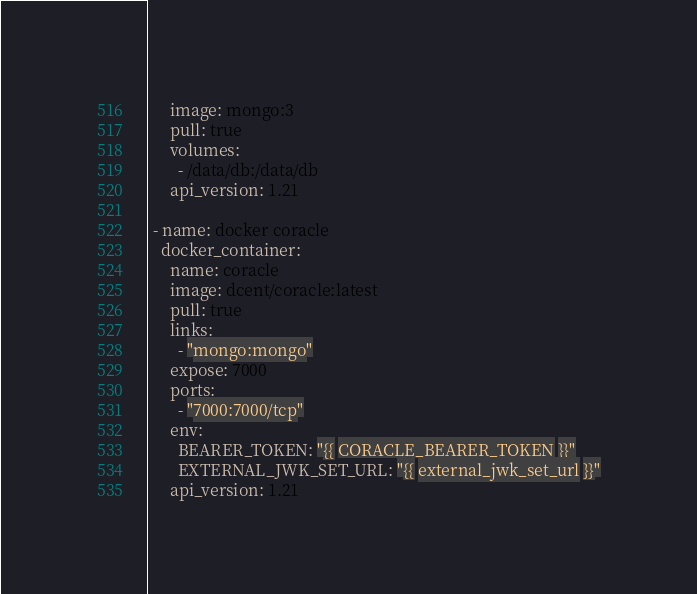Convert code to text. <code><loc_0><loc_0><loc_500><loc_500><_YAML_>     image: mongo:3
     pull: true
     volumes:
       - /data/db:/data/db
     api_version: 1.21

 - name: docker coracle
   docker_container:
     name: coracle
     image: dcent/coracle:latest
     pull: true
     links:
       - "mongo:mongo"
     expose: 7000
     ports:
       - "7000:7000/tcp"
     env:
       BEARER_TOKEN: "{{ CORACLE_BEARER_TOKEN }}"
       EXTERNAL_JWK_SET_URL: "{{ external_jwk_set_url }}"
     api_version: 1.21</code> 